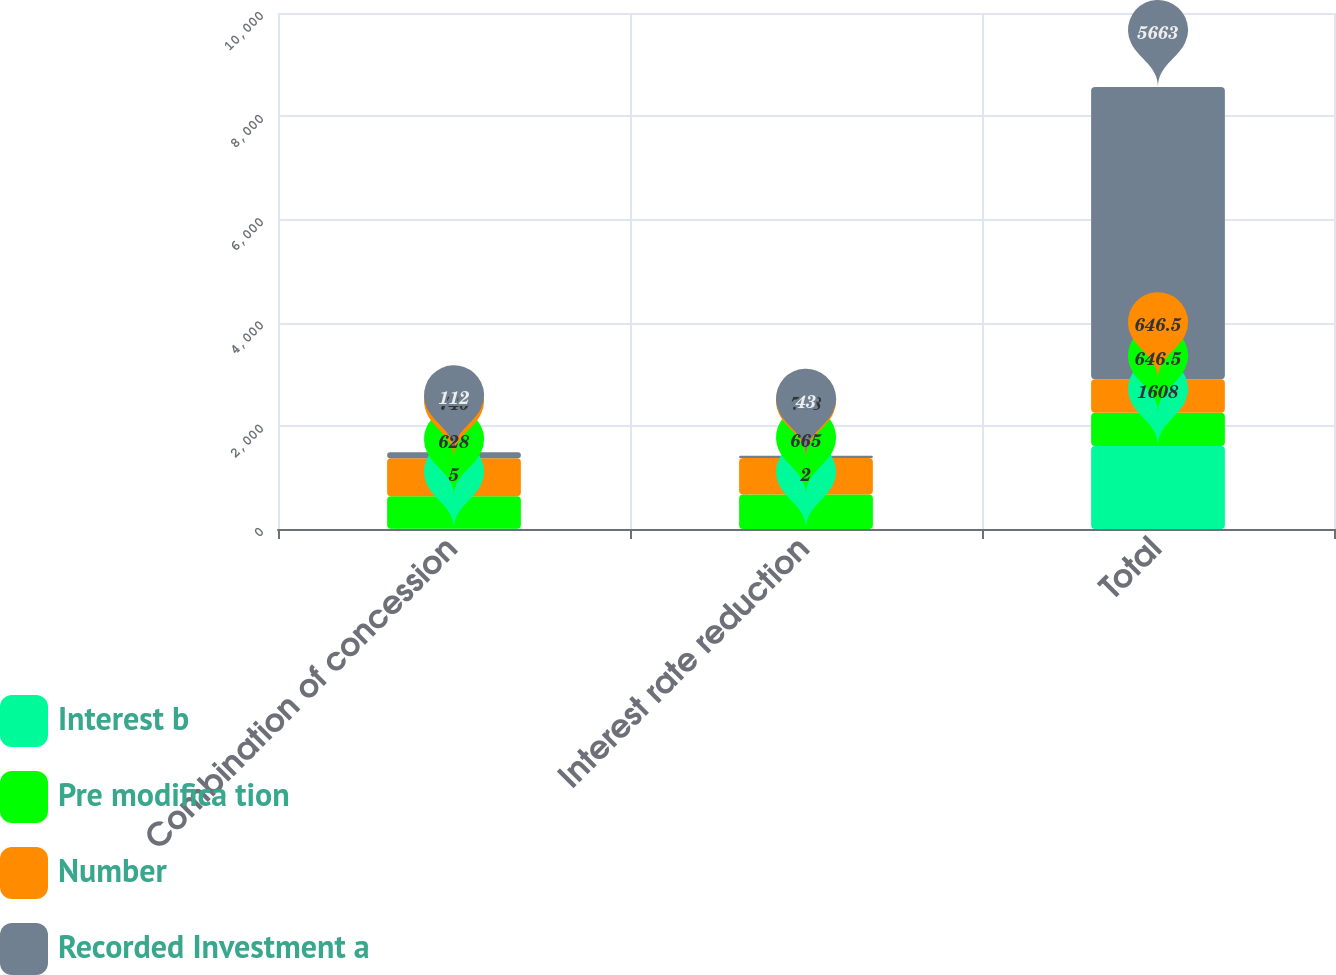Convert chart to OTSL. <chart><loc_0><loc_0><loc_500><loc_500><stacked_bar_chart><ecel><fcel>Combination of concession<fcel>Interest rate reduction<fcel>Total<nl><fcel>Interest b<fcel>5<fcel>2<fcel>1608<nl><fcel>Pre modifica tion<fcel>628<fcel>665<fcel>646.5<nl><fcel>Number<fcel>740<fcel>708<fcel>646.5<nl><fcel>Recorded Investment a<fcel>112<fcel>43<fcel>5663<nl></chart> 